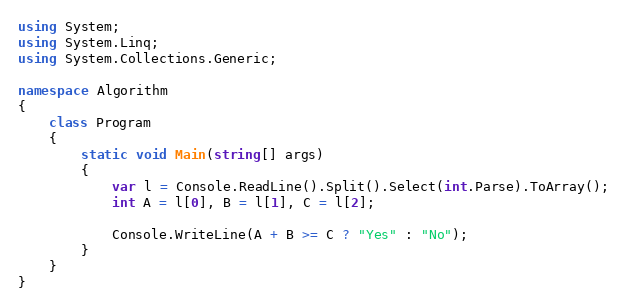Convert code to text. <code><loc_0><loc_0><loc_500><loc_500><_C#_>using System;
using System.Linq;
using System.Collections.Generic;

namespace Algorithm
{
    class Program
    {
        static void Main(string[] args)
        {
            var l = Console.ReadLine().Split().Select(int.Parse).ToArray();
            int A = l[0], B = l[1], C = l[2];

            Console.WriteLine(A + B >= C ? "Yes" : "No");
        }
    }
}
</code> 